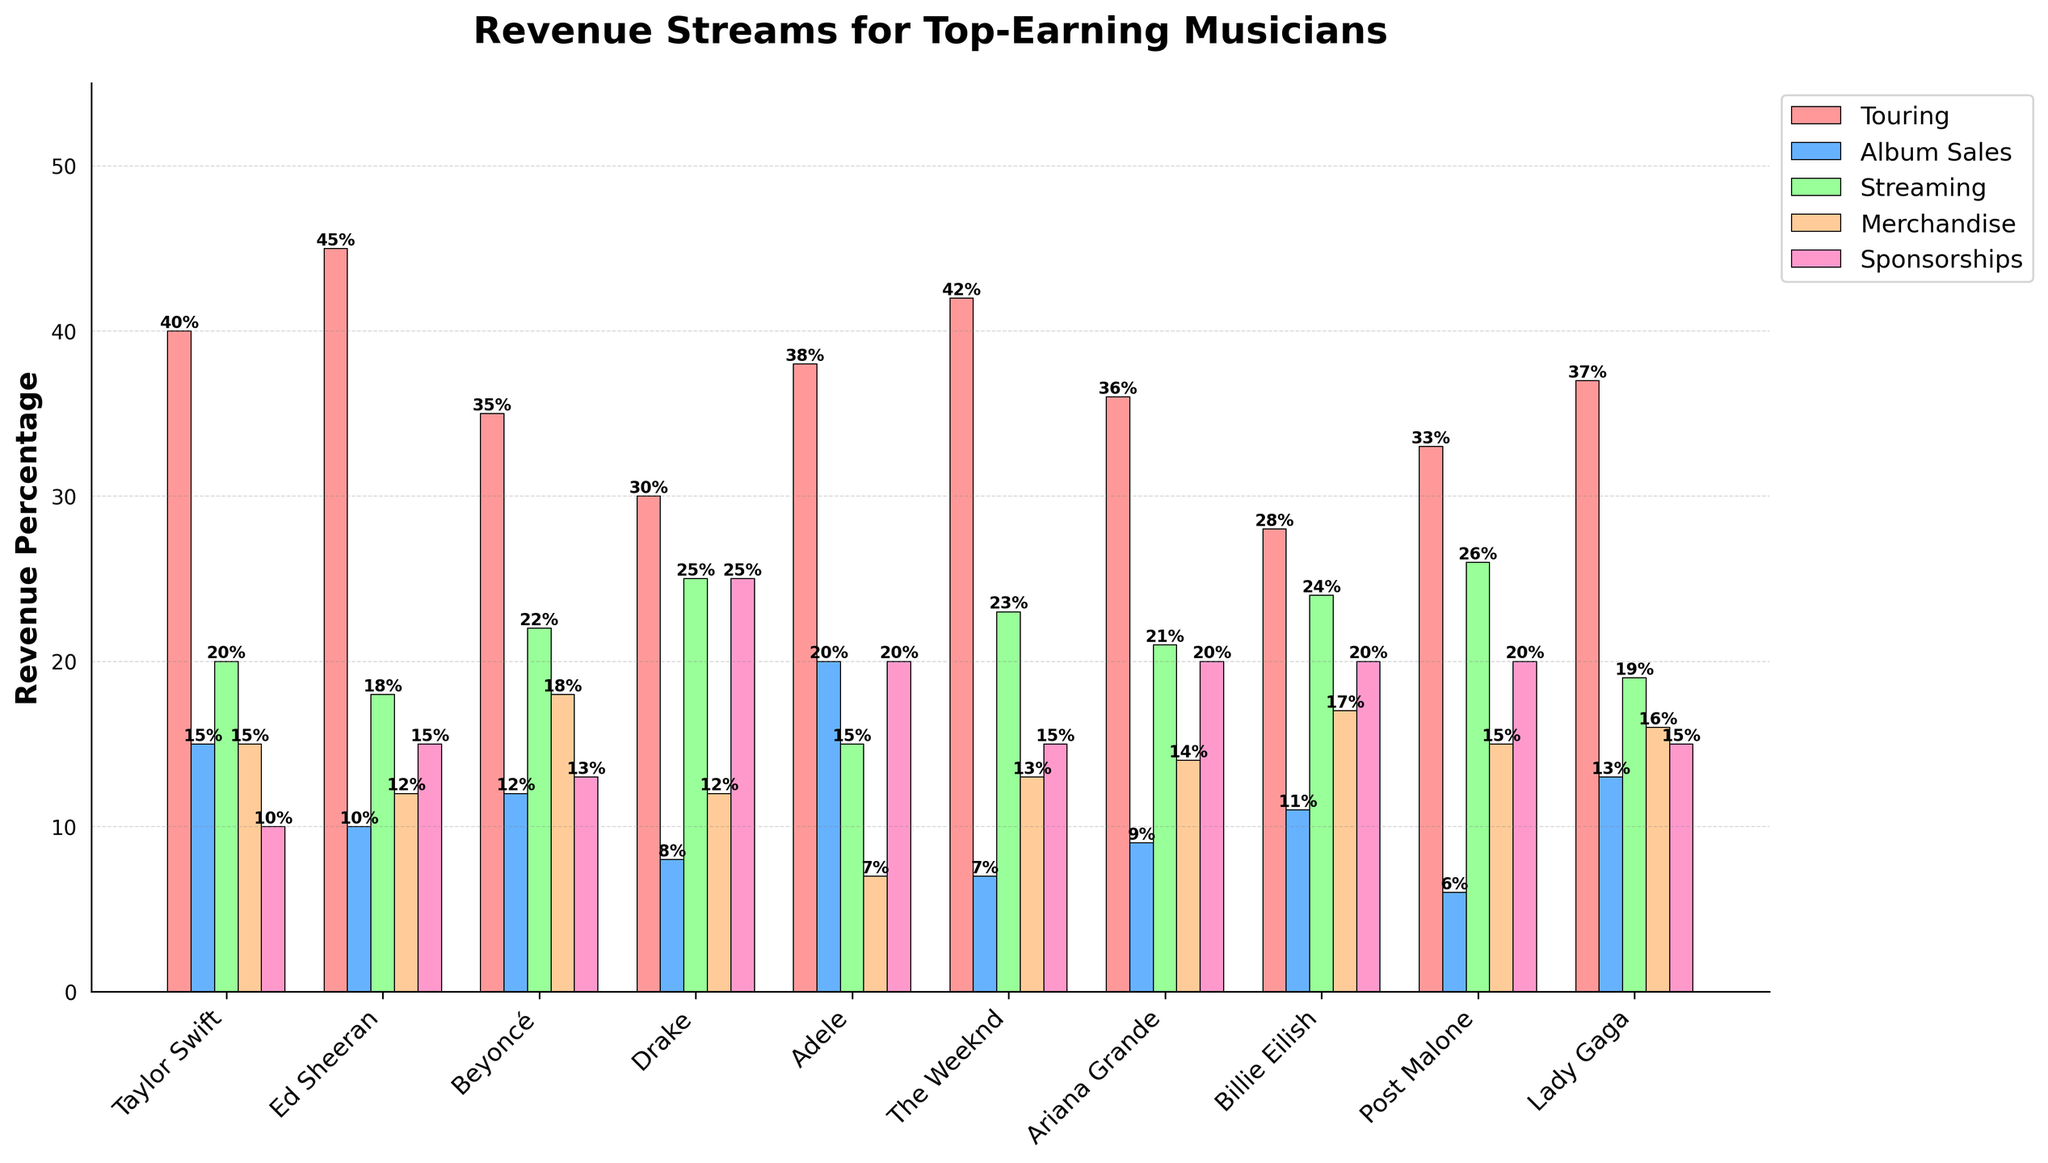Which artist has the highest revenue from touring? By looking at the heights of the bars corresponding to touring revenues, we see that Ed Sheeran's touring bar is the tallest.
Answer: Ed Sheeran What is the total revenue percentage from album sales for Taylor Swift and Adele? From the bar chart, Taylor Swift has 15% and Adele has 20% from album sales. Adding these together: 15 + 20 = 35%.
Answer: 35% Which revenue stream is the highest for Drake? For Drake, the tallest bar corresponds to the 'Sponsorships' revenue stream.
Answer: Sponsorships Which artist has the lowest revenue percentage from merchandising? By comparing the heights of the merchandise bars, Adele has the lowest bar at 7%.
Answer: Adele What is the difference in streaming revenue between Billie Eilish and The Weeknd? Billie Eilish has 24% and The Weeknd has 23% from streaming. The difference is 24 - 23 = 1%.
Answer: 1% What is the average revenue percentage from sponsorships across all artists? Sum the sponsorship percentages: 10+15+13+25+20+15+20+20+20+15 = 173. There are 10 artists, so the average is 173/10 = 17.3%.
Answer: 17.3% For which artist is merchandise revenue the highest? Comparing the heights of the merchandise bars, Beyoncé has the highest bar at 18%.
Answer: Beyoncé Considering only album sales and streaming, who earns more, Lady Gaga or Post Malone? Lady Gaga has 13% from album sales and 19% from streaming, totaling 32%. Post Malone has 6% from album sales and 26% from streaming, totaling 32%. They earn the same.
Answer: They earn the same If we sum the sponsorships and album sales for Taylor Swift and Ed Sheeran, who has a higher total? Taylor Swift: 10 (sponsorships) + 15 (album sales) = 25. Ed Sheeran: 15 (sponsorships) + 10 (album sales) = 25. They both have the same total.
Answer: They have the same total 